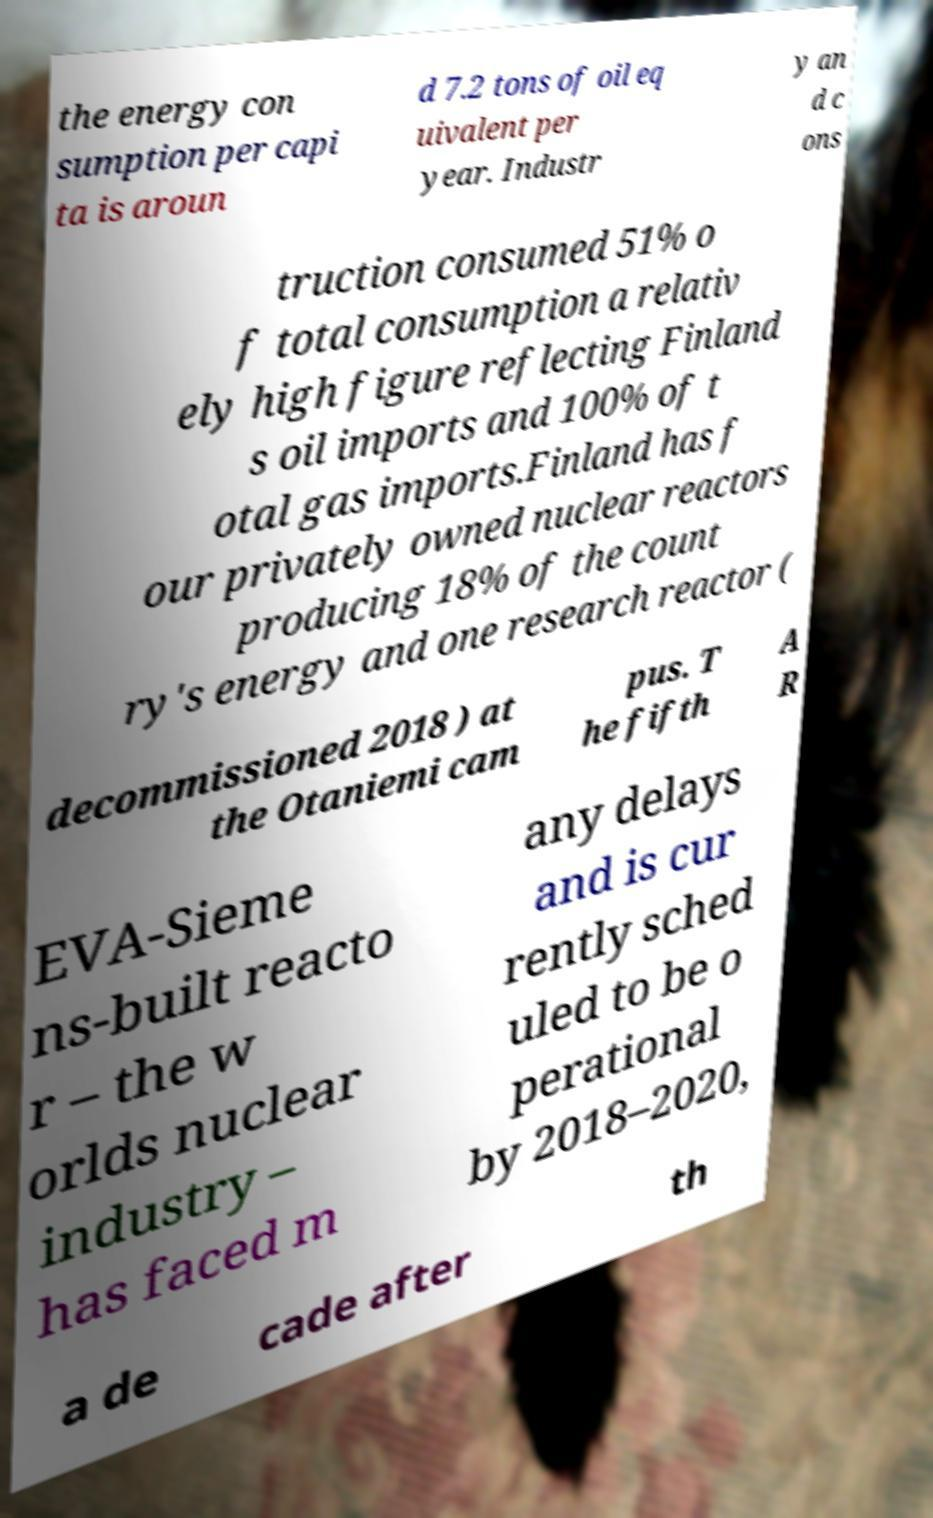Could you extract and type out the text from this image? the energy con sumption per capi ta is aroun d 7.2 tons of oil eq uivalent per year. Industr y an d c ons truction consumed 51% o f total consumption a relativ ely high figure reflecting Finland s oil imports and 100% of t otal gas imports.Finland has f our privately owned nuclear reactors producing 18% of the count ry's energy and one research reactor ( decommissioned 2018 ) at the Otaniemi cam pus. T he fifth A R EVA-Sieme ns-built reacto r – the w orlds nuclear industry – has faced m any delays and is cur rently sched uled to be o perational by 2018–2020, a de cade after th 